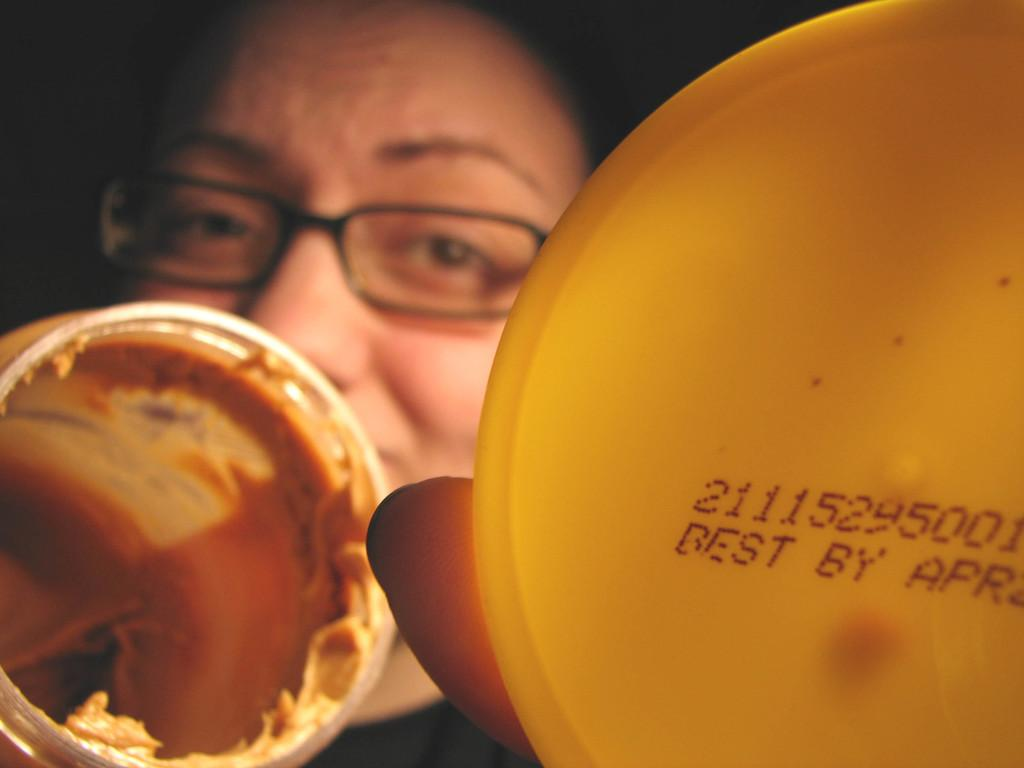What is the main subject of the image? There is a person in the image. What is the person holding in the image? The person is holding a jar and a cap. What can be observed about the background of the image? The background of the image is dark. How many rings can be seen on the person's fingers in the image? There are no rings visible on the person's fingers in the image. What is the taste of the jar's contents in the image? The taste of the jar's contents cannot be determined from the image, as it does not provide any sensory information. 